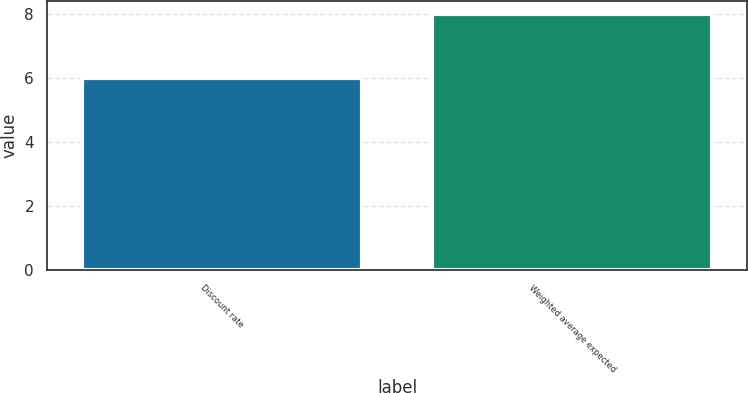Convert chart. <chart><loc_0><loc_0><loc_500><loc_500><bar_chart><fcel>Discount rate<fcel>Weighted average expected<nl><fcel>6<fcel>8<nl></chart> 